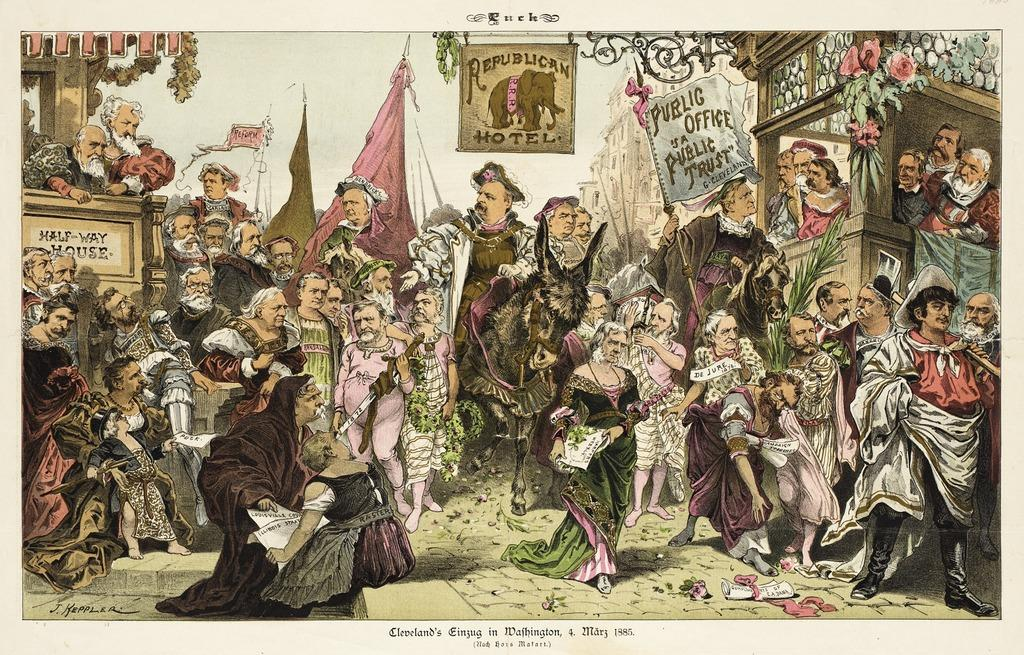Provide a one-sentence caption for the provided image. an oldtimey style political drawing of a lot of people with Republican Motel on one of the banners. 